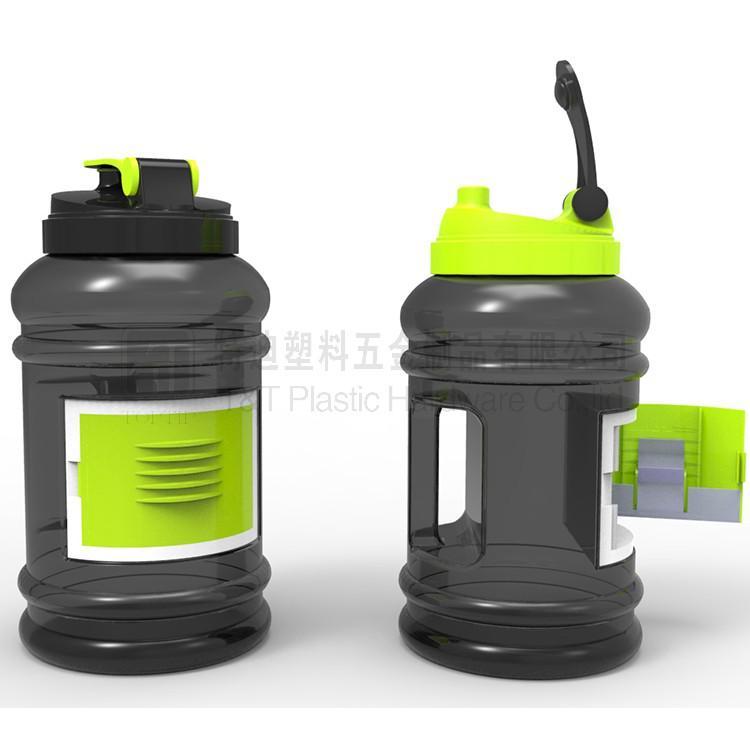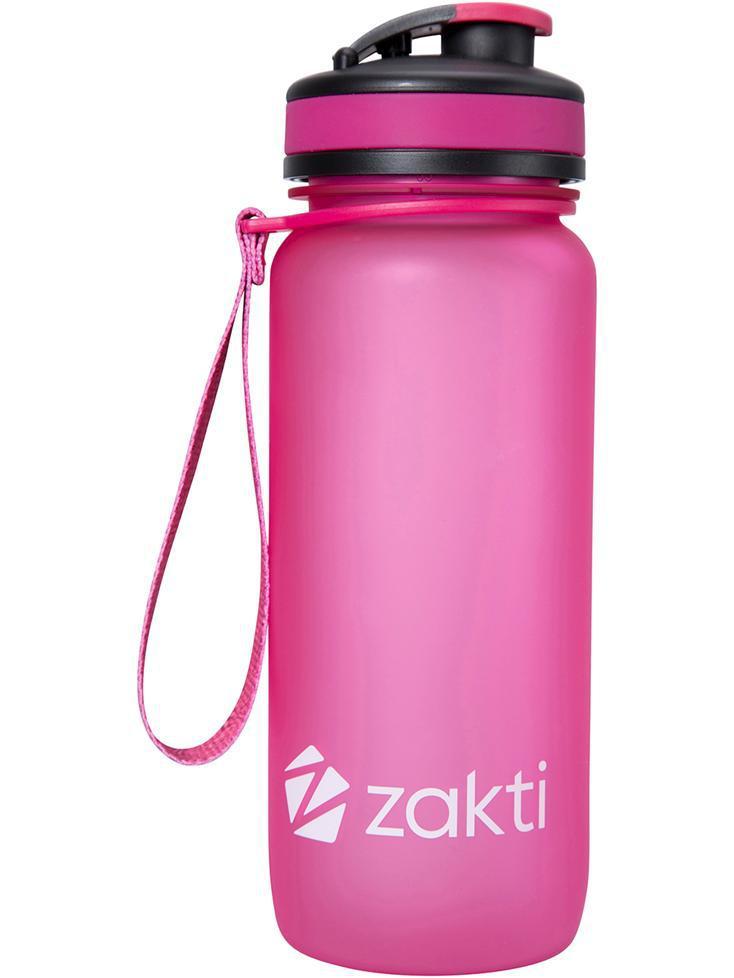The first image is the image on the left, the second image is the image on the right. For the images shown, is this caption "At least one water bottle is jug-shaped with a built-in side handle and a flip top, and one water bottle is hot pink." true? Answer yes or no. Yes. The first image is the image on the left, the second image is the image on the right. For the images displayed, is the sentence "There are three plastic drinking containers with lids." factually correct? Answer yes or no. Yes. 